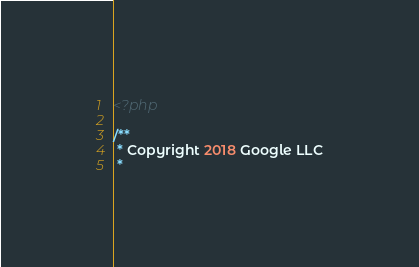Convert code to text. <code><loc_0><loc_0><loc_500><loc_500><_PHP_><?php

/**
 * Copyright 2018 Google LLC
 *</code> 